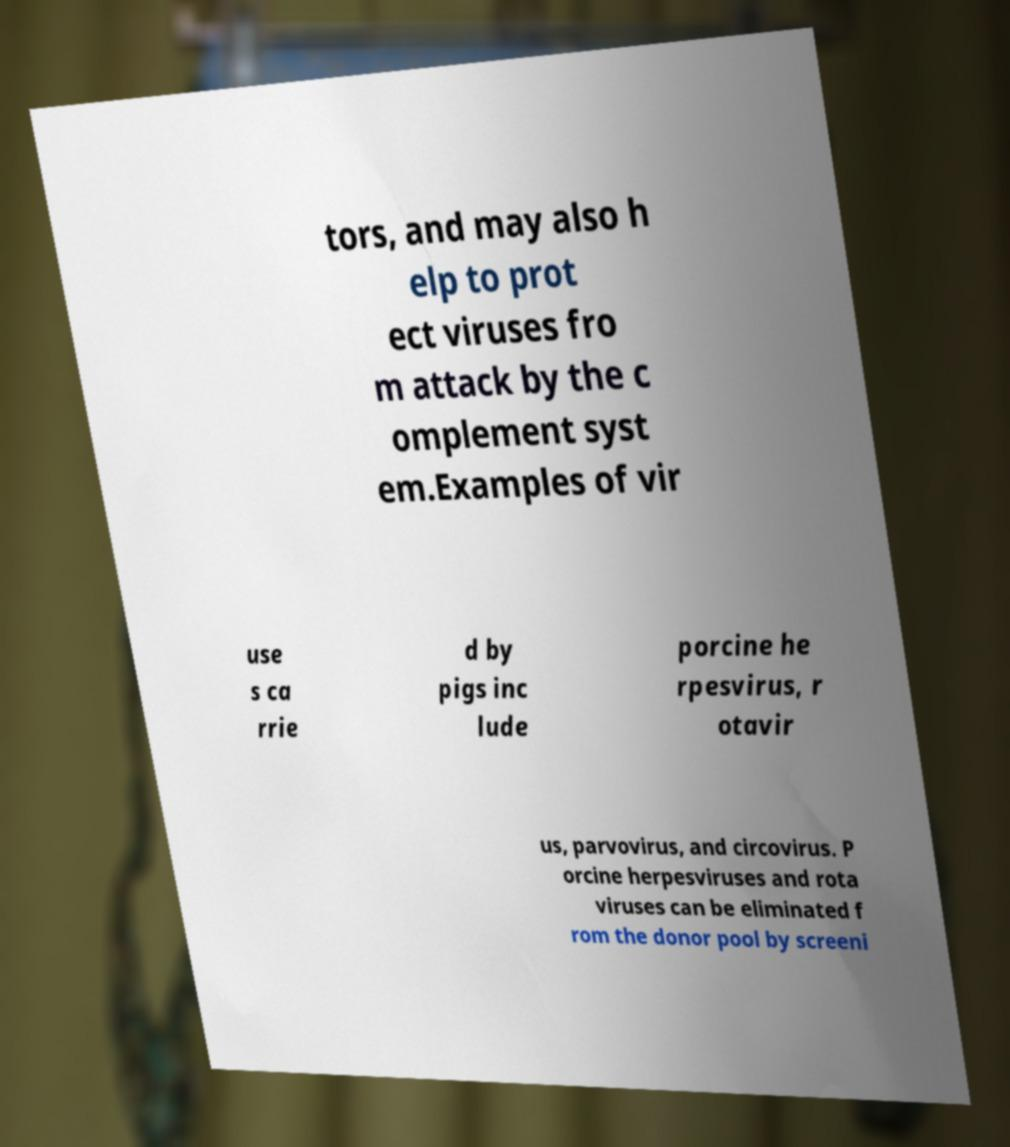Please read and relay the text visible in this image. What does it say? tors, and may also h elp to prot ect viruses fro m attack by the c omplement syst em.Examples of vir use s ca rrie d by pigs inc lude porcine he rpesvirus, r otavir us, parvovirus, and circovirus. P orcine herpesviruses and rota viruses can be eliminated f rom the donor pool by screeni 